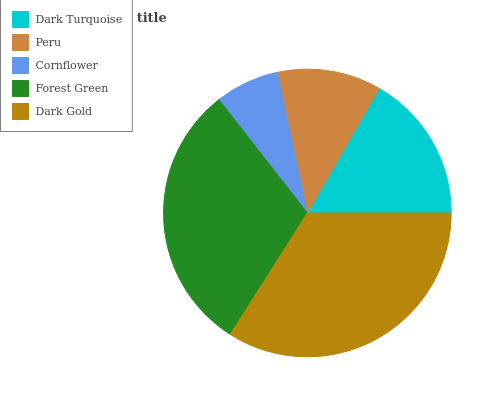Is Cornflower the minimum?
Answer yes or no. Yes. Is Dark Gold the maximum?
Answer yes or no. Yes. Is Peru the minimum?
Answer yes or no. No. Is Peru the maximum?
Answer yes or no. No. Is Dark Turquoise greater than Peru?
Answer yes or no. Yes. Is Peru less than Dark Turquoise?
Answer yes or no. Yes. Is Peru greater than Dark Turquoise?
Answer yes or no. No. Is Dark Turquoise less than Peru?
Answer yes or no. No. Is Dark Turquoise the high median?
Answer yes or no. Yes. Is Dark Turquoise the low median?
Answer yes or no. Yes. Is Forest Green the high median?
Answer yes or no. No. Is Dark Gold the low median?
Answer yes or no. No. 